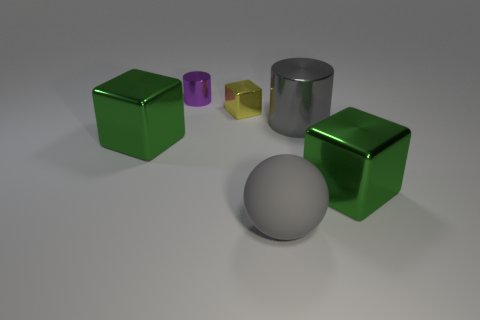How big is the metallic cube that is both to the left of the large cylinder and in front of the big gray shiny object?
Provide a short and direct response. Large. Is the number of metal things to the right of the gray ball greater than the number of yellow metallic objects to the left of the yellow block?
Provide a short and direct response. Yes. The rubber sphere that is the same color as the big shiny cylinder is what size?
Your answer should be compact. Large. The tiny cylinder has what color?
Keep it short and to the point. Purple. What color is the large object that is both in front of the gray cylinder and on the right side of the sphere?
Your response must be concise. Green. There is a big cube that is in front of the large green block to the left of the cylinder in front of the tiny purple shiny cylinder; what color is it?
Keep it short and to the point. Green. What is the color of the cylinder that is the same size as the gray ball?
Provide a short and direct response. Gray. What shape is the large green metal object on the left side of the cube that is in front of the large green shiny thing to the left of the small purple shiny cylinder?
Keep it short and to the point. Cube. There is a large thing that is the same color as the big matte sphere; what shape is it?
Provide a succinct answer. Cylinder. What number of objects are either shiny things or large metallic cubes to the right of the small shiny cylinder?
Give a very brief answer. 5. 